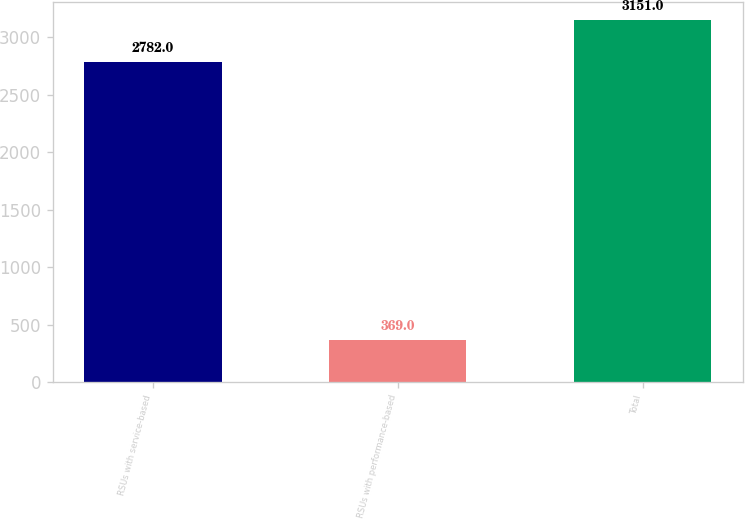Convert chart. <chart><loc_0><loc_0><loc_500><loc_500><bar_chart><fcel>RSUs with service-based<fcel>RSUs with performance-based<fcel>Total<nl><fcel>2782<fcel>369<fcel>3151<nl></chart> 